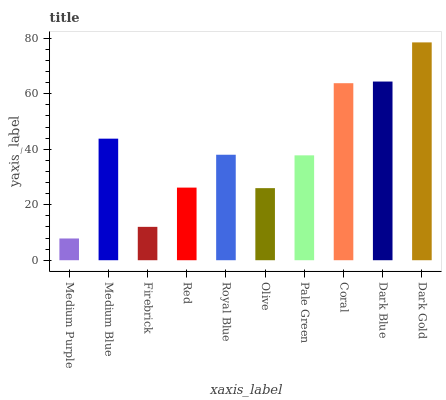Is Medium Purple the minimum?
Answer yes or no. Yes. Is Dark Gold the maximum?
Answer yes or no. Yes. Is Medium Blue the minimum?
Answer yes or no. No. Is Medium Blue the maximum?
Answer yes or no. No. Is Medium Blue greater than Medium Purple?
Answer yes or no. Yes. Is Medium Purple less than Medium Blue?
Answer yes or no. Yes. Is Medium Purple greater than Medium Blue?
Answer yes or no. No. Is Medium Blue less than Medium Purple?
Answer yes or no. No. Is Royal Blue the high median?
Answer yes or no. Yes. Is Pale Green the low median?
Answer yes or no. Yes. Is Medium Blue the high median?
Answer yes or no. No. Is Dark Gold the low median?
Answer yes or no. No. 